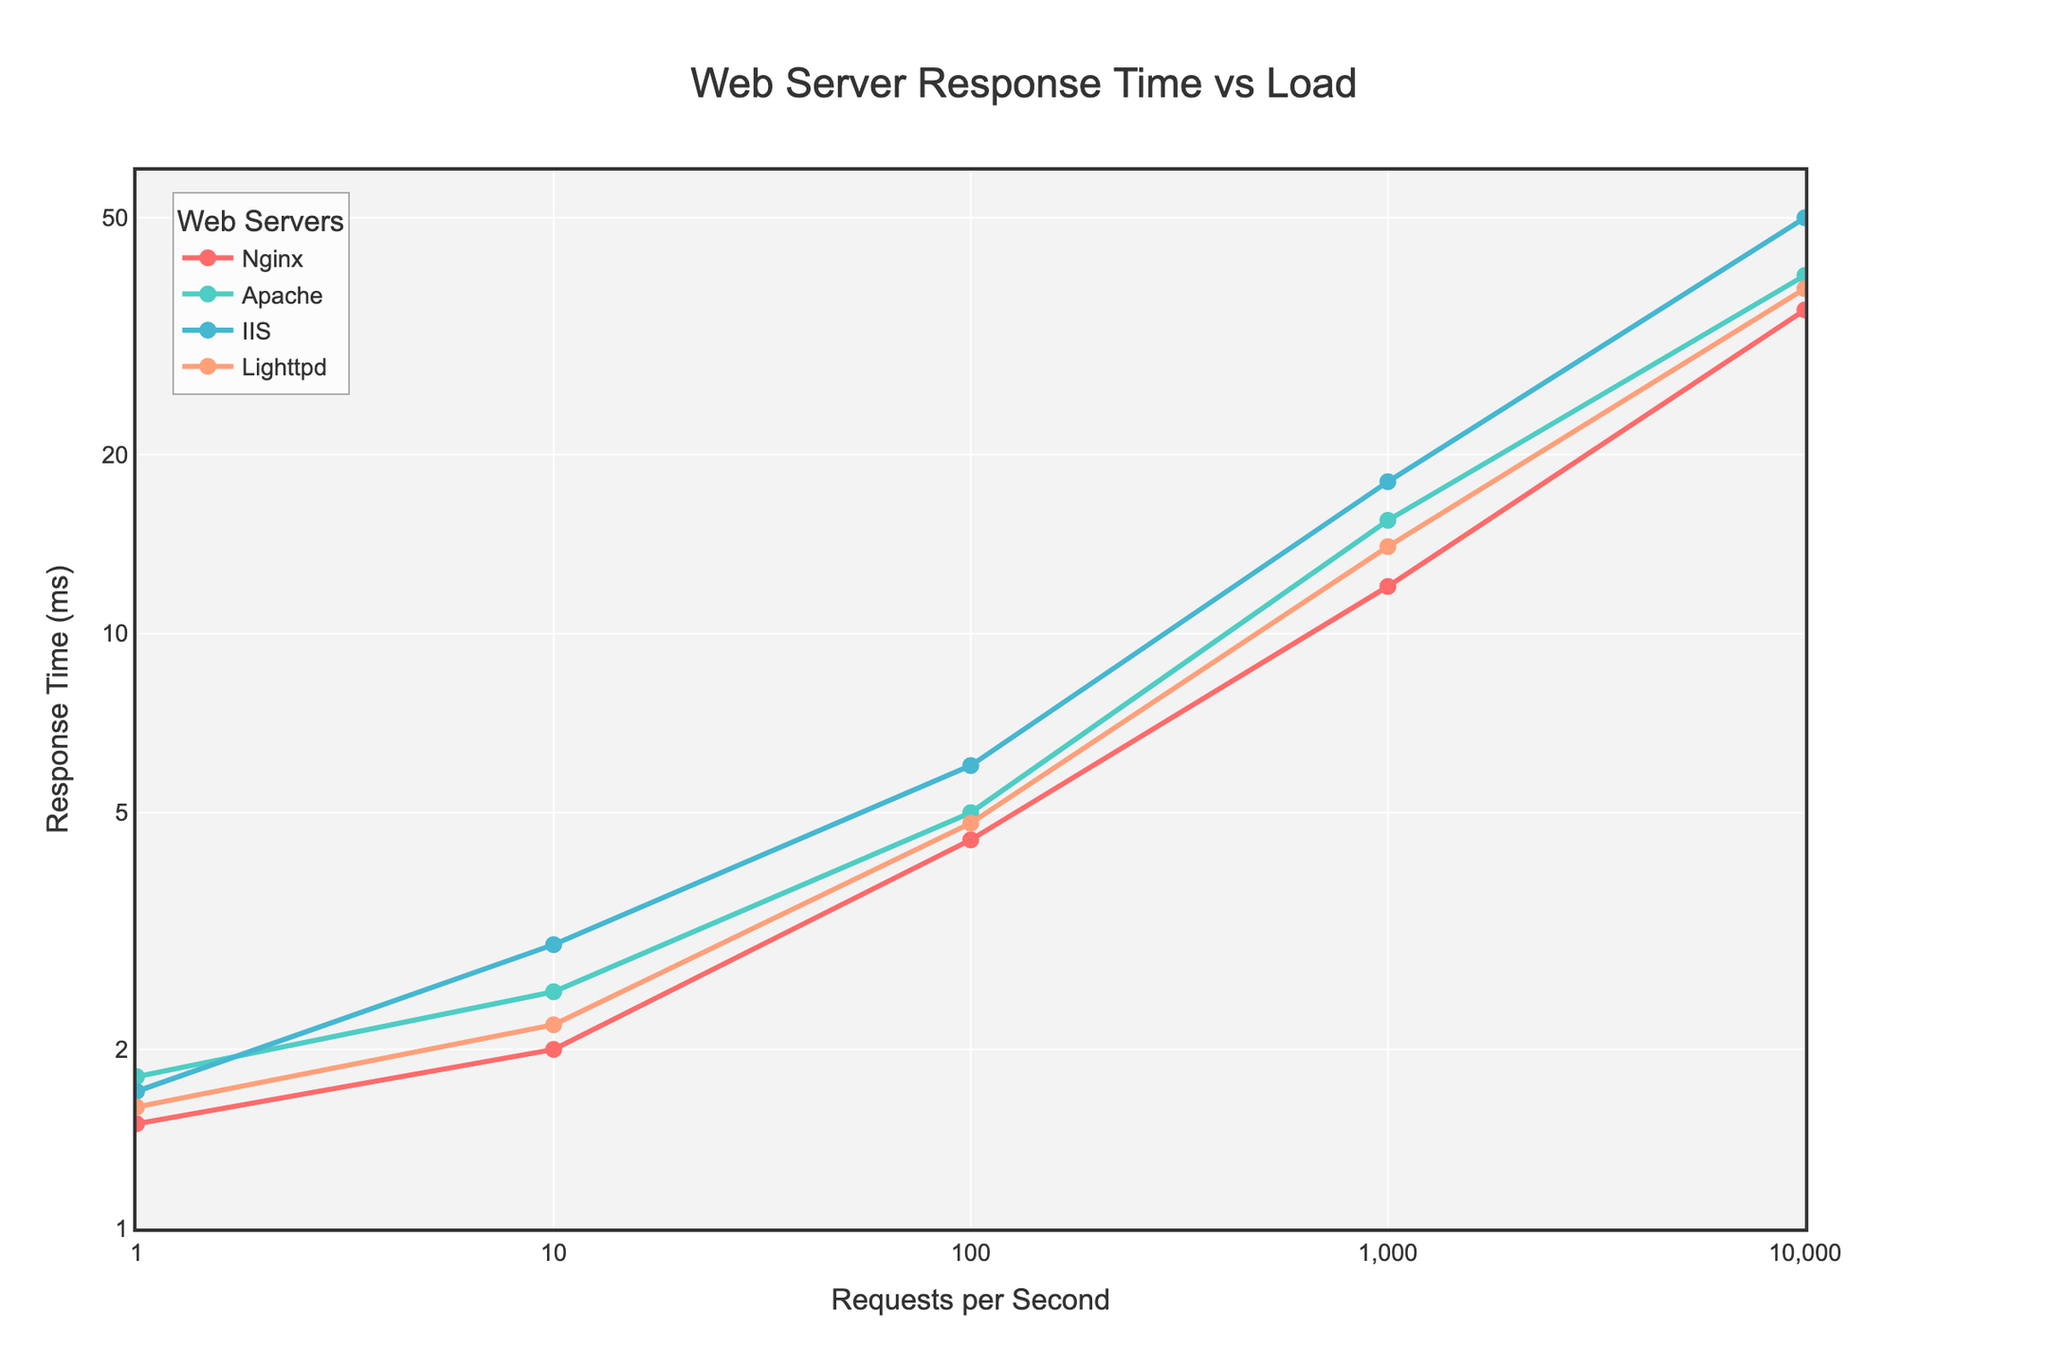What's the title of the figure? The title is located at the top center of the figure, making it clear and immediately visible. It gives a summary of what the figure represents.
Answer: "Web Server Response Time vs Load" What is the y-axis label? The y-axis label can be found on the left side of the plot, indicating what is being measured on this axis.
Answer: "Response Time (ms)" Which server has the highest response time at 10,000 requests per second? Look at the data points at 10,000 requests per second on the x-axis and check which server corresponds to the highest y-value.
Answer: IIS How does Nginx’s response time change as the load increases from 10 to 1,000 requests per second? Observe the data points for Nginx at 10 and 1,000 requests per second and note how the y-value changes.
Answer: It increases from 2.0 ms to 12.0 ms Between Apache and Lighttpd, which server responds faster at 100 requests per second? Compare the y-values for Apache and Lighttpd at 100 requests per second on the x-axis. The lower y-value indicates a faster response time.
Answer: Lighttpd What is the difference in response time between Nginx and IIS at 100 requests per second? Identify the response times for Nginx and IIS at 100 requests per second and subtract the smaller value from the larger one.
Answer: 1.5 ms If a load of 1,000 requests per second is applied to all servers, which one has the shortest response time? Check the response times for all servers at 1,000 requests per second and identify the one with the smallest y-value.
Answer: Nginx Are the response times of all servers plotted on a linear or logarithmic scale on the y-axis? Observe the layout of the y-axis; the spacing between values increases logarithmically rather than linearly.
Answer: Logarithmic scale How does the trend in response times for Apache compare to Nginx as the load increases from 1 to 10,000 requests per second? Observe the slopes of the lines representing Apache and Nginx. Check if both increase similarly or differently as the load increases.
Answer: Both increase, but Nginx has a slightly lower response time across the range Which web server has a more consistent response time as the load increases, considering the slope of the line? A more consistent response time is indicated by a flatter slope. Check which line appears flatter between servers.
Answer: Nginx 